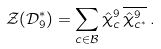<formula> <loc_0><loc_0><loc_500><loc_500>\mathcal { Z } ( \mathcal { D } _ { 9 } ^ { * } ) = \sum _ { c \in \mathcal { B } } \hat { \chi } ^ { 9 } _ { c } \, \overline { \hat { \chi } ^ { 9 } _ { c ^ { * } } } \, .</formula> 